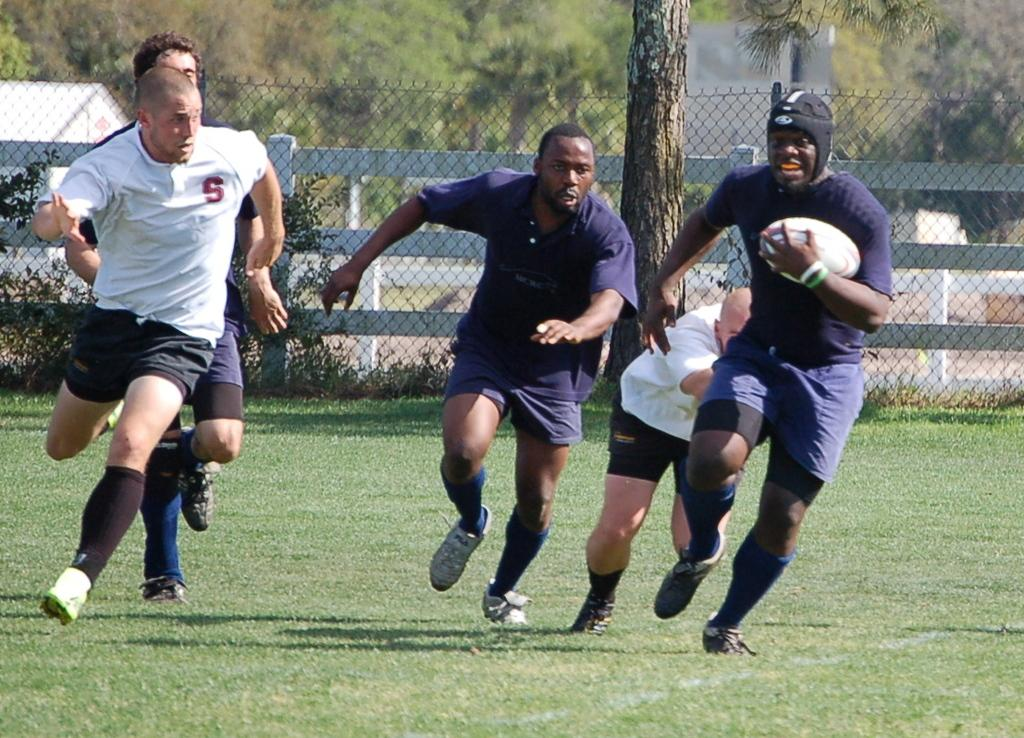What is the main feature of the image? There is a playground in the image. What can be seen surrounding the playground? There is a fence in the image. What natural elements are visible in the image? There are trees visible in the image. What activity are the players engaged in? The players are playing a ball in the image. What action are the players taking while playing the ball? The players are running. What type of tomatoes are being grown in the territory shown in the image? There is no territory or tomatoes present in the image; it features a playground, a fence, trees, and players playing a ball. 